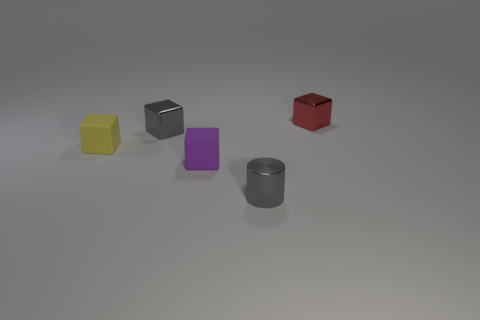Subtract all red cylinders. Subtract all blue spheres. How many cylinders are left? 1 Add 2 big matte cubes. How many objects exist? 7 Subtract all cubes. How many objects are left? 1 Subtract all small brown blocks. Subtract all tiny purple things. How many objects are left? 4 Add 2 red shiny things. How many red shiny things are left? 3 Add 1 metallic blocks. How many metallic blocks exist? 3 Subtract 1 gray blocks. How many objects are left? 4 